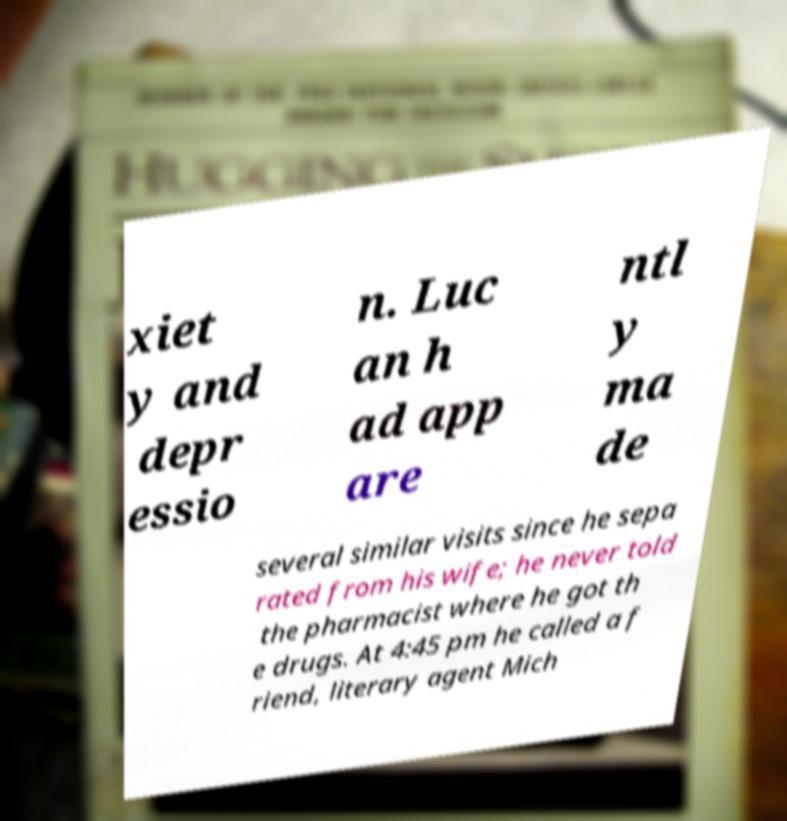Can you accurately transcribe the text from the provided image for me? xiet y and depr essio n. Luc an h ad app are ntl y ma de several similar visits since he sepa rated from his wife; he never told the pharmacist where he got th e drugs. At 4:45 pm he called a f riend, literary agent Mich 